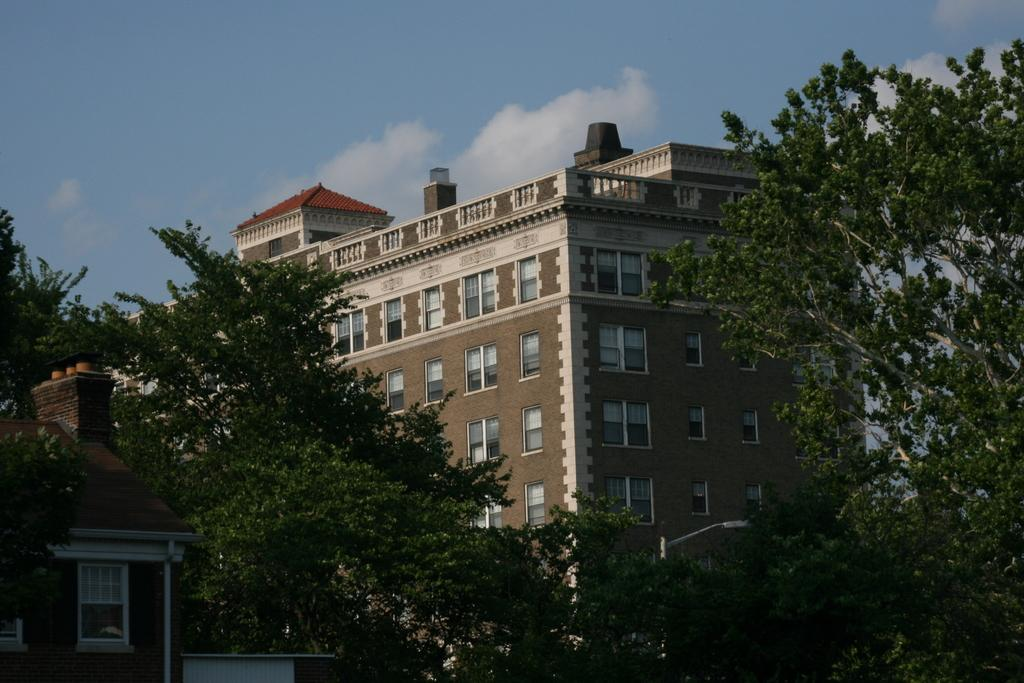What type of structures are present in the image? There are buildings in the image. What feature do the buildings have? The buildings have windows. What type of vegetation can be seen on both sides of the image? There are trees on the left side and the right side of the image. What is visible at the top of the image? The sky is visible at the top of the image. Can you tell me how many dinosaurs are roaming around in the image? There are no dinosaurs present in the image; it features buildings, trees, and a sky. What type of feast is being prepared in the image? There is no feast being prepared in the image; it only shows buildings, trees, and the sky. 